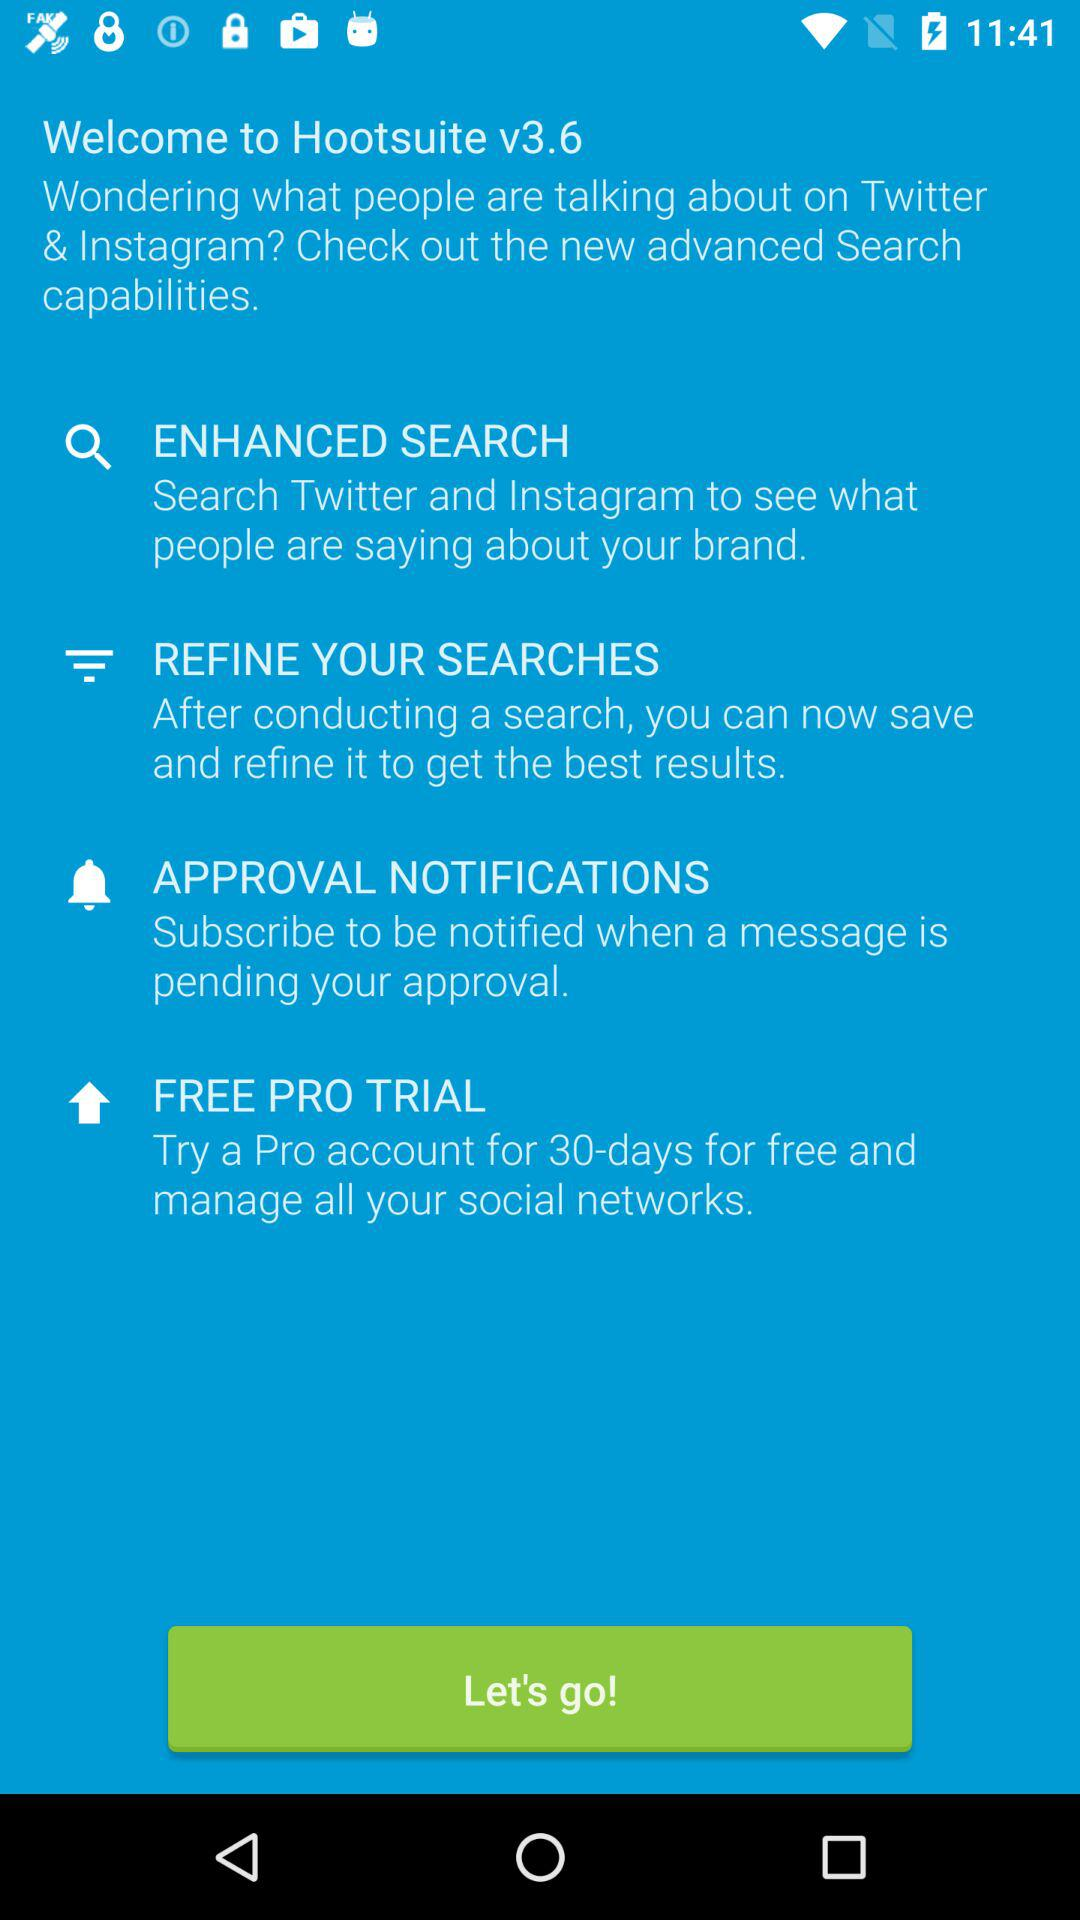How many more features are there in the new version that are related to search compared to the old version?
Answer the question using a single word or phrase. 2 